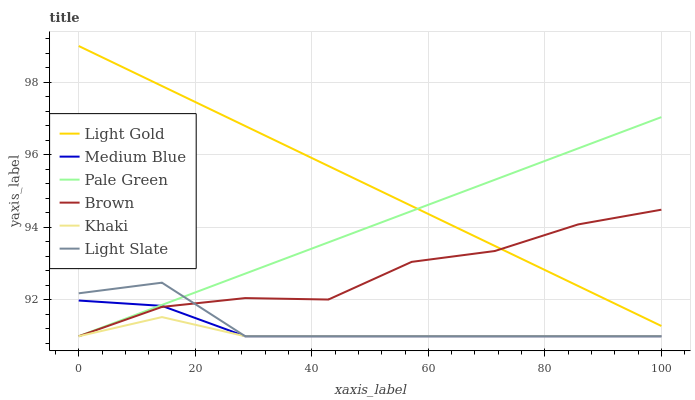Does Khaki have the minimum area under the curve?
Answer yes or no. Yes. Does Light Gold have the maximum area under the curve?
Answer yes or no. Yes. Does Light Slate have the minimum area under the curve?
Answer yes or no. No. Does Light Slate have the maximum area under the curve?
Answer yes or no. No. Is Light Gold the smoothest?
Answer yes or no. Yes. Is Brown the roughest?
Answer yes or no. Yes. Is Khaki the smoothest?
Answer yes or no. No. Is Khaki the roughest?
Answer yes or no. No. Does Light Gold have the lowest value?
Answer yes or no. No. Does Light Gold have the highest value?
Answer yes or no. Yes. Does Light Slate have the highest value?
Answer yes or no. No. Is Khaki less than Light Gold?
Answer yes or no. Yes. Is Light Gold greater than Medium Blue?
Answer yes or no. Yes. Does Brown intersect Khaki?
Answer yes or no. Yes. Is Brown less than Khaki?
Answer yes or no. No. Is Brown greater than Khaki?
Answer yes or no. No. Does Khaki intersect Light Gold?
Answer yes or no. No. 